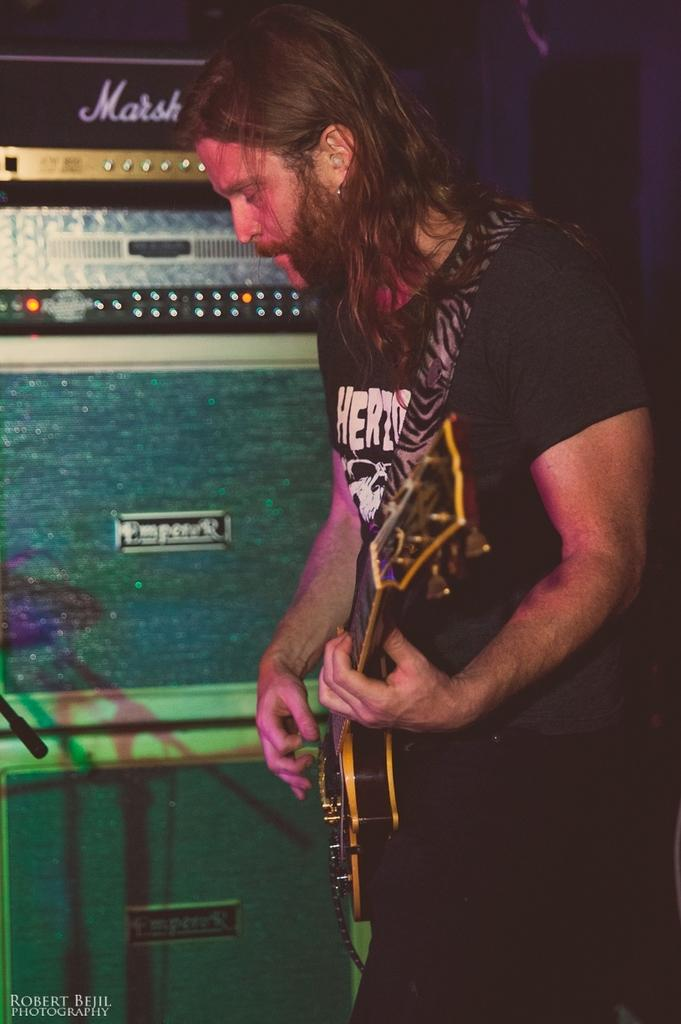What is the main subject of the image? There is a person in the image. What is the person doing in the image? The person is standing and playing a guitar. What type of stone is being used as a kite in the image? There is no stone or kite present in the image; it features a person standing and playing a guitar. 